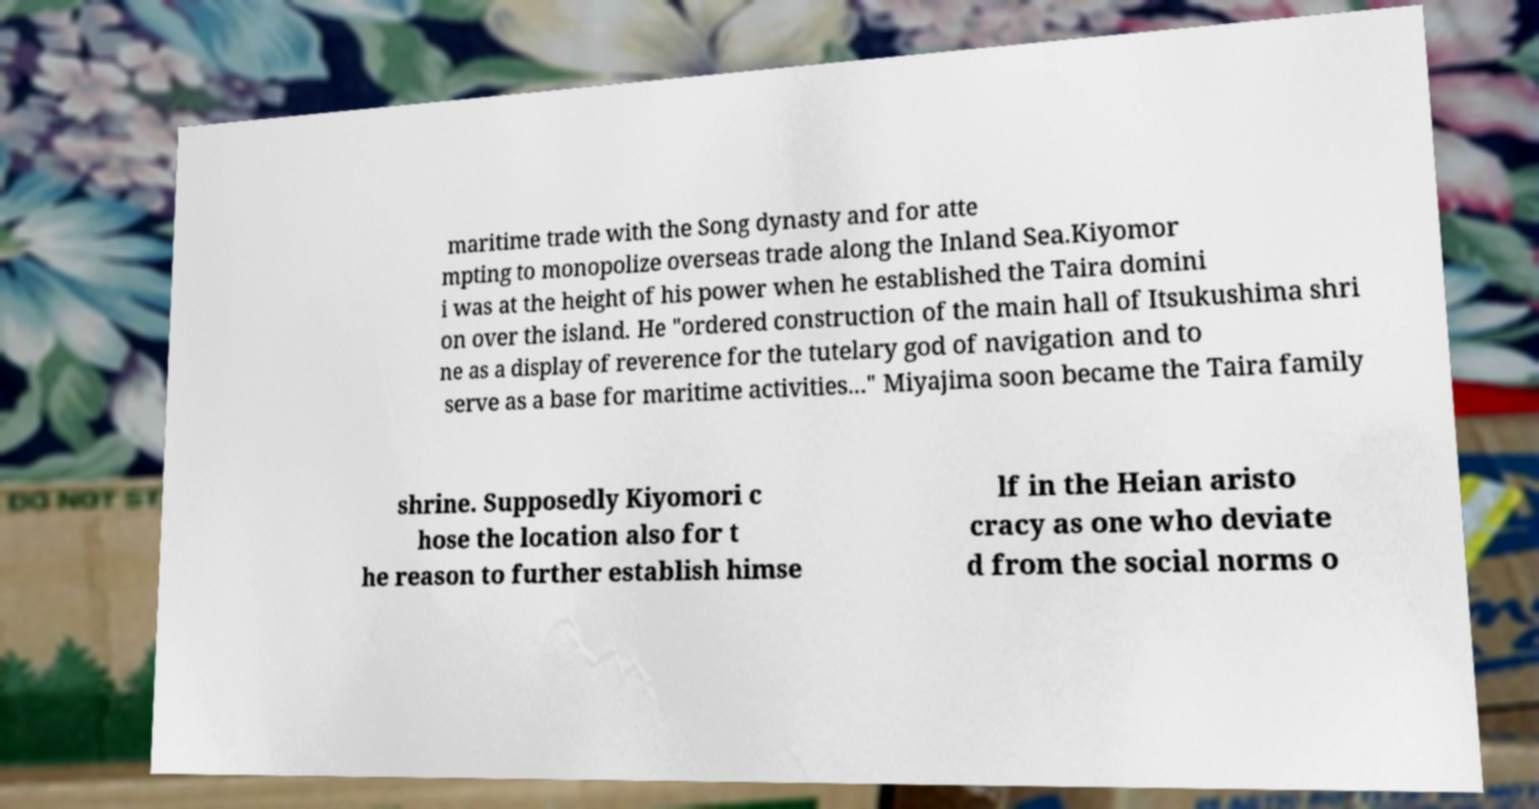What messages or text are displayed in this image? I need them in a readable, typed format. maritime trade with the Song dynasty and for atte mpting to monopolize overseas trade along the Inland Sea.Kiyomor i was at the height of his power when he established the Taira domini on over the island. He "ordered construction of the main hall of Itsukushima shri ne as a display of reverence for the tutelary god of navigation and to serve as a base for maritime activities..." Miyajima soon became the Taira family shrine. Supposedly Kiyomori c hose the location also for t he reason to further establish himse lf in the Heian aristo cracy as one who deviate d from the social norms o 